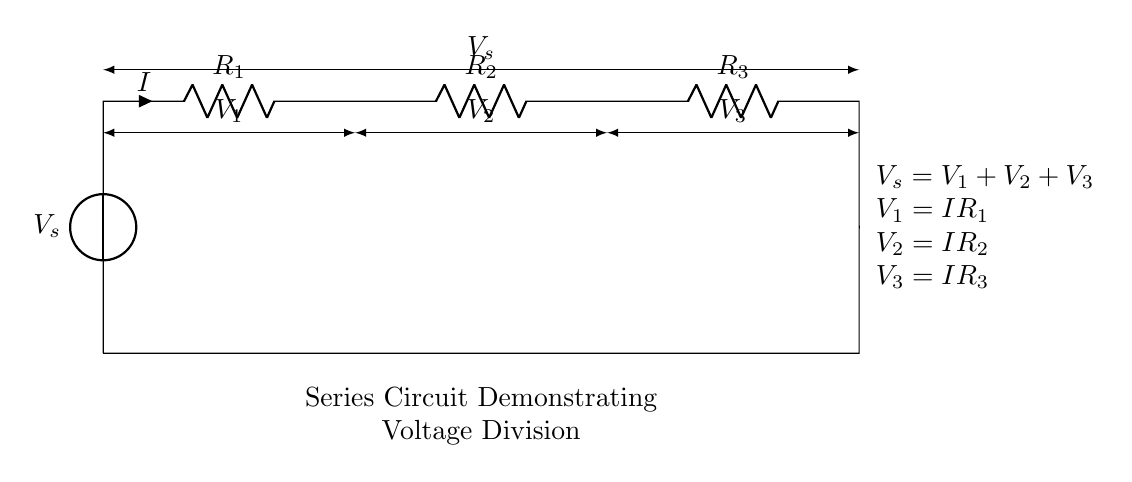What is the type of circuit depicted? The circuit is a series circuit as indicated by the connection of the resistors in a single path for current to flow.
Answer: Series circuit What is the total supply voltage? The total supply voltage is denoted as V_s, which is presented at the circuit's voltage source.
Answer: V_s How many resistors are in this circuit? There are three resistors connected in series, as shown by the symbols for R_1, R_2, and R_3.
Answer: Three What is the formula representing the relationship between the voltages? The formula shown indicates that the total voltage V_s is equal to the sum of the individual voltages across the resistors: V_s = V_1 + V_2 + V_3.
Answer: V_s = V_1 + V_2 + V_3 If R_1 is larger than R_2 and R_3, how will it affect the voltage across R_1? According to the voltage division principle, a larger resistor in a series circuit will drop a larger voltage, so V_1 will be greater than V_2 and V_3.
Answer: Larger voltage across R_1 What is the relationship between current and resistance in this series circuit? The current remains constant throughout the series circuit, but the voltage drop across each resistor depends on its resistance according to Ohm's law (V = IR).
Answer: Constant current How does the voltage drop across each resistor relate to their resistances? The voltage drop across each resistor is directly proportional to its resistance. Thus, V_1 = IR_1, V_2 = IR_2, V_3 = IR_3 indicates that larger resistors will have larger voltage drops.
Answer: Directly proportional 